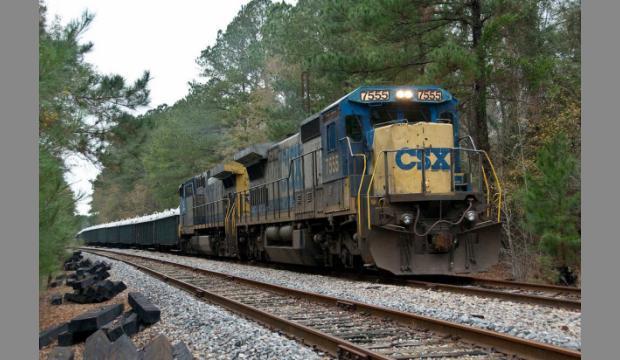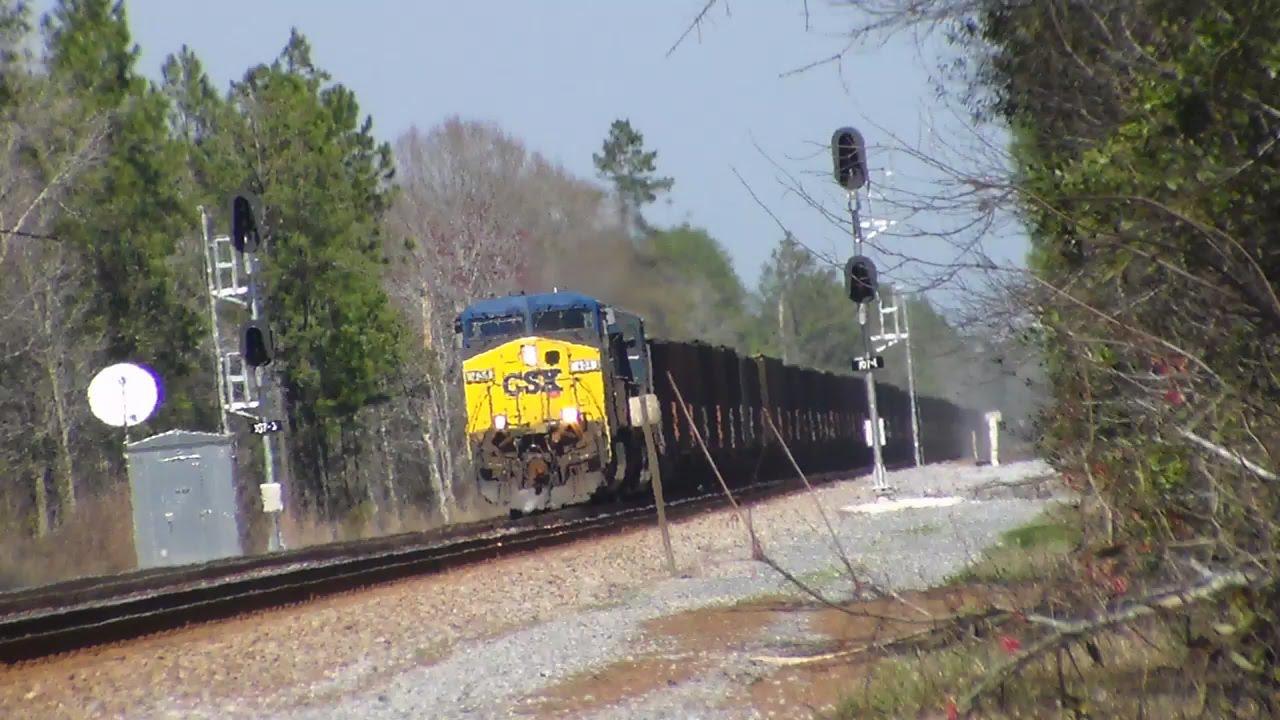The first image is the image on the left, the second image is the image on the right. Evaluate the accuracy of this statement regarding the images: "Left image shows a blue and yellow train that his heading rightward.". Is it true? Answer yes or no. Yes. The first image is the image on the left, the second image is the image on the right. Analyze the images presented: Is the assertion "A total of two trains are headed on the same direction." valid? Answer yes or no. No. 